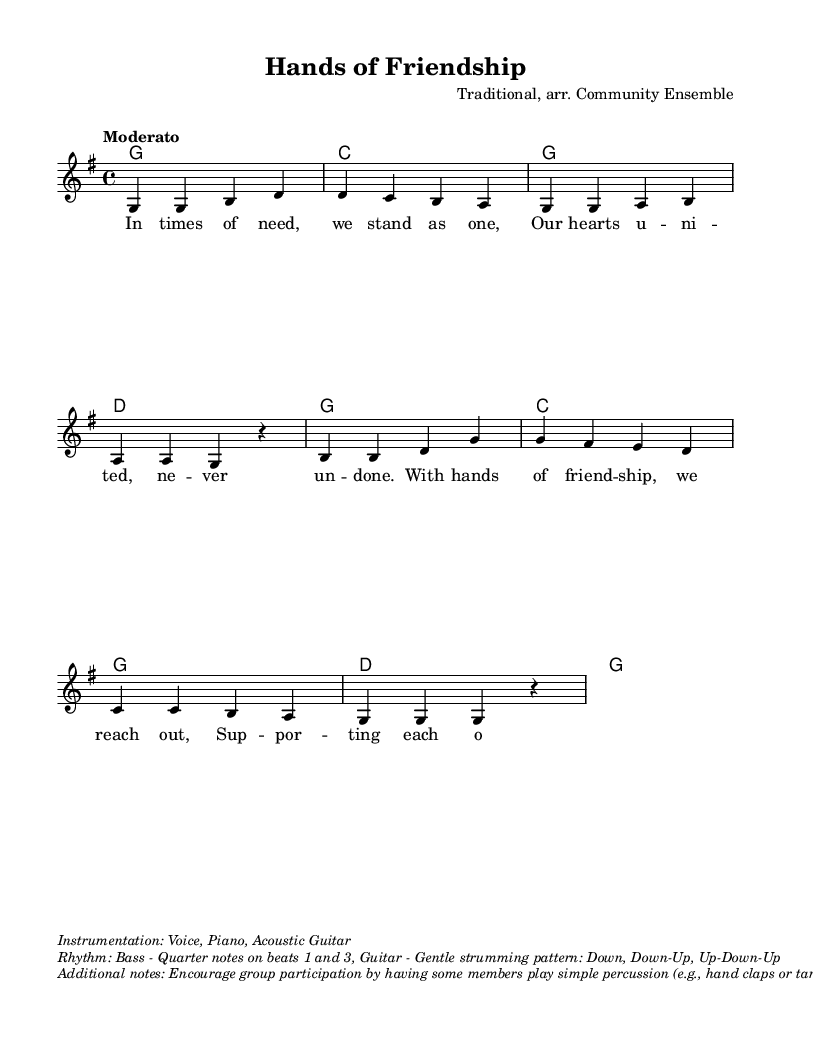What is the key signature of this music? The key signature is G major, which has one sharp (F#). We can identify the key signature at the beginning of the staff where the sharp is placed.
Answer: G major What is the time signature of this music? The time signature is 4/4, indicated right after the key signature. It shows that there are four beats per measure, and the quarter note gets one beat.
Answer: 4/4 What is the tempo marking of this piece? The tempo marking is "Moderato," which typically indicates a moderate pace of the piece. This can often be found at the beginning of the score.
Answer: Moderato How many measures are in the piece? By counting the groups of notes and the vertical lines (bar lines), we see there are eight measures in total. Each measure is separated by a vertical line.
Answer: Eight What is the primary theme of the lyrics? The primary theme of the lyrics is community support and friendship, which is evident through the words that emphasize unity and helping each other.
Answer: Community support What instruments are indicated for this piece? The instrumentation indicated includes Voice, Piano, and Acoustic Guitar, which is listed in the markup section below the score.
Answer: Voice, Piano, Acoustic Guitar What additional participation is suggested for group involvement? The suggestion includes having group members play simple percussion instruments, such as hand claps or tambourine, to enhance participation, especially for those with mobility constraints.
Answer: Simple percussion 